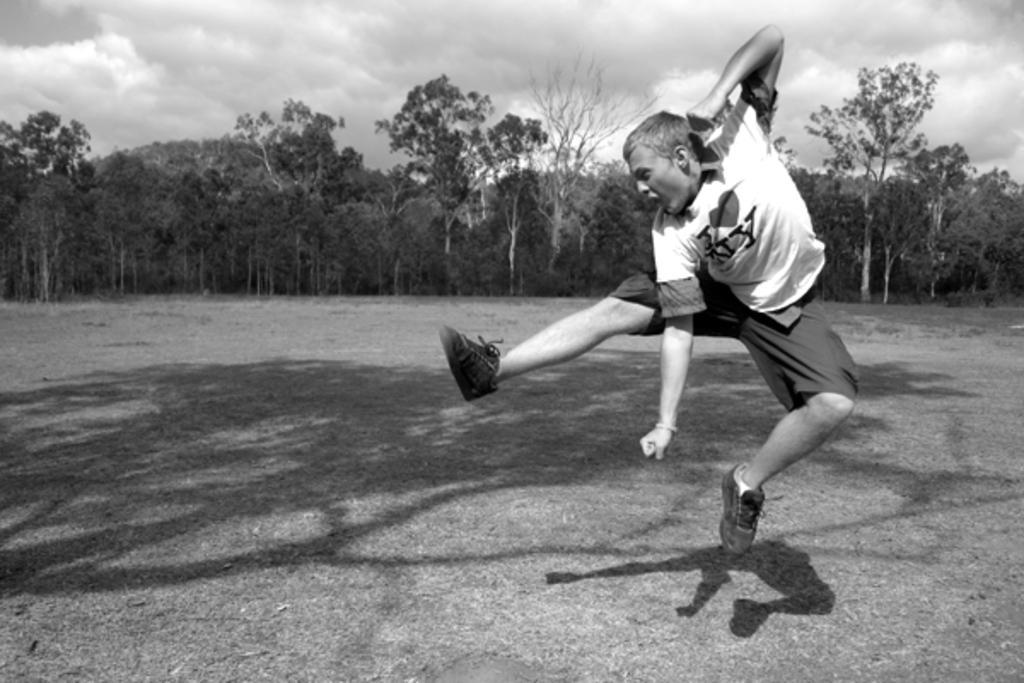Please provide a concise description of this image. This is a black and white image and here we can see a person jumping and in the background, there are trees. At the top, there are clouds in the sky and at the bottom, there is ground. 